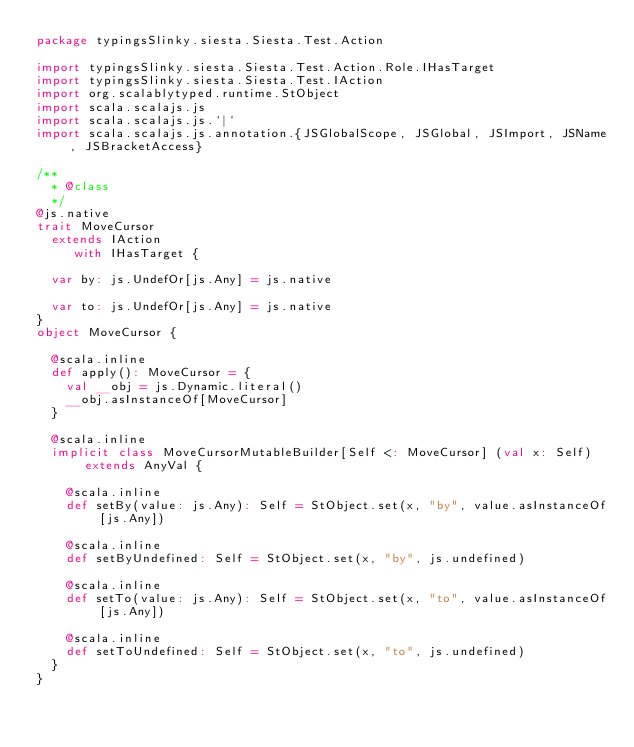<code> <loc_0><loc_0><loc_500><loc_500><_Scala_>package typingsSlinky.siesta.Siesta.Test.Action

import typingsSlinky.siesta.Siesta.Test.Action.Role.IHasTarget
import typingsSlinky.siesta.Siesta.Test.IAction
import org.scalablytyped.runtime.StObject
import scala.scalajs.js
import scala.scalajs.js.`|`
import scala.scalajs.js.annotation.{JSGlobalScope, JSGlobal, JSImport, JSName, JSBracketAccess}

/**
  * @class
  */
@js.native
trait MoveCursor
  extends IAction
     with IHasTarget {
  
  var by: js.UndefOr[js.Any] = js.native
  
  var to: js.UndefOr[js.Any] = js.native
}
object MoveCursor {
  
  @scala.inline
  def apply(): MoveCursor = {
    val __obj = js.Dynamic.literal()
    __obj.asInstanceOf[MoveCursor]
  }
  
  @scala.inline
  implicit class MoveCursorMutableBuilder[Self <: MoveCursor] (val x: Self) extends AnyVal {
    
    @scala.inline
    def setBy(value: js.Any): Self = StObject.set(x, "by", value.asInstanceOf[js.Any])
    
    @scala.inline
    def setByUndefined: Self = StObject.set(x, "by", js.undefined)
    
    @scala.inline
    def setTo(value: js.Any): Self = StObject.set(x, "to", value.asInstanceOf[js.Any])
    
    @scala.inline
    def setToUndefined: Self = StObject.set(x, "to", js.undefined)
  }
}
</code> 